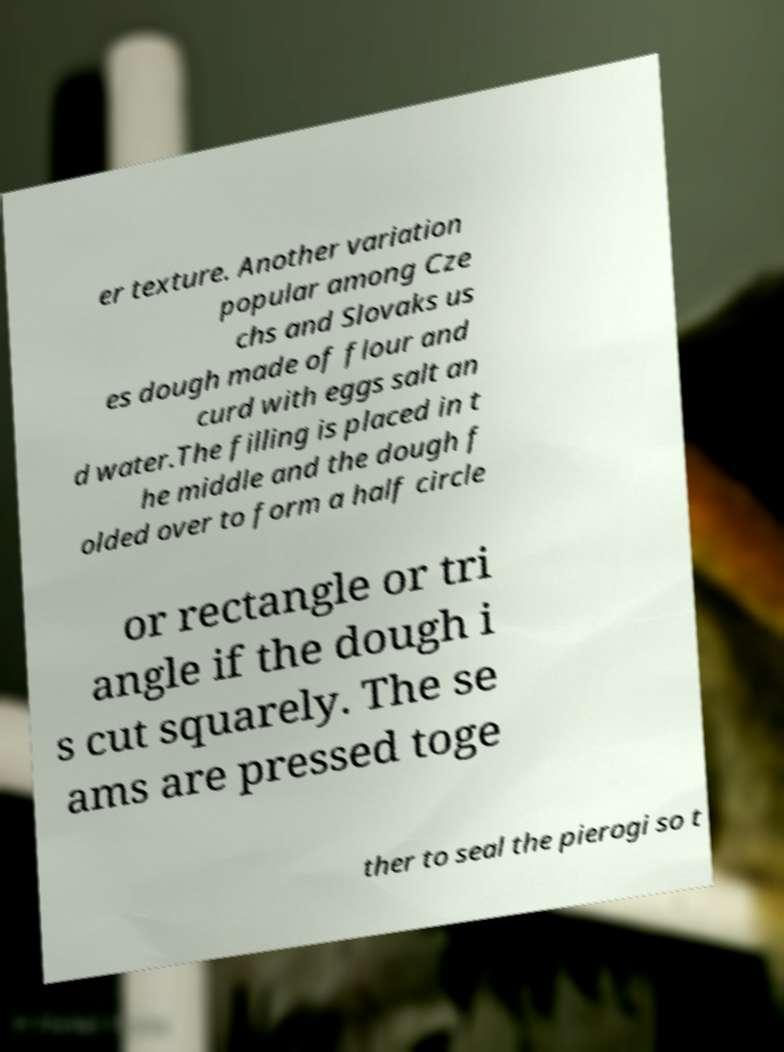What messages or text are displayed in this image? I need them in a readable, typed format. er texture. Another variation popular among Cze chs and Slovaks us es dough made of flour and curd with eggs salt an d water.The filling is placed in t he middle and the dough f olded over to form a half circle or rectangle or tri angle if the dough i s cut squarely. The se ams are pressed toge ther to seal the pierogi so t 